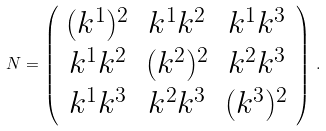Convert formula to latex. <formula><loc_0><loc_0><loc_500><loc_500>N = \left ( \begin{array} { c c c } ( k ^ { 1 } ) ^ { 2 } & k ^ { 1 } k ^ { 2 } & k ^ { 1 } k ^ { 3 } \\ k ^ { 1 } k ^ { 2 } & ( k ^ { 2 } ) ^ { 2 } & k ^ { 2 } k ^ { 3 } \\ k ^ { 1 } k ^ { 3 } & k ^ { 2 } k ^ { 3 } & ( k ^ { 3 } ) ^ { 2 } \end{array} \right ) \, .</formula> 